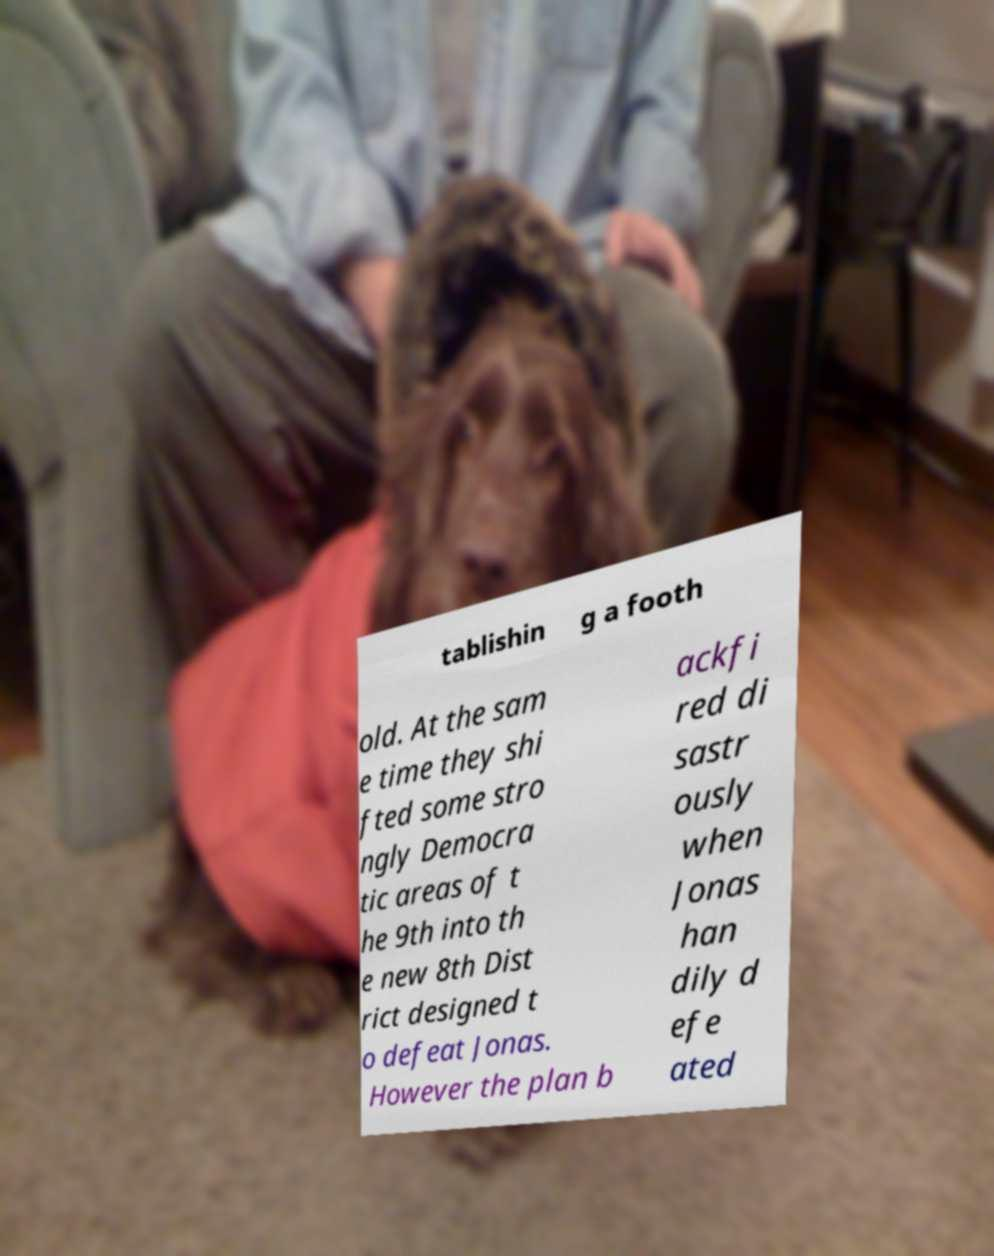For documentation purposes, I need the text within this image transcribed. Could you provide that? tablishin g a footh old. At the sam e time they shi fted some stro ngly Democra tic areas of t he 9th into th e new 8th Dist rict designed t o defeat Jonas. However the plan b ackfi red di sastr ously when Jonas han dily d efe ated 